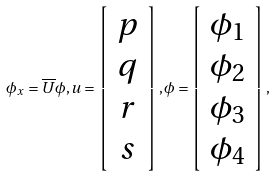<formula> <loc_0><loc_0><loc_500><loc_500>\phi _ { x } = \overline { U } \phi , u = \left [ \begin{array} { c } p \\ q \\ r \\ s \end{array} \right ] , \phi = \left [ \begin{array} { c } \phi _ { 1 } \\ \phi _ { 2 } \\ \phi _ { 3 } \\ \phi _ { 4 } \end{array} \right ] ,</formula> 